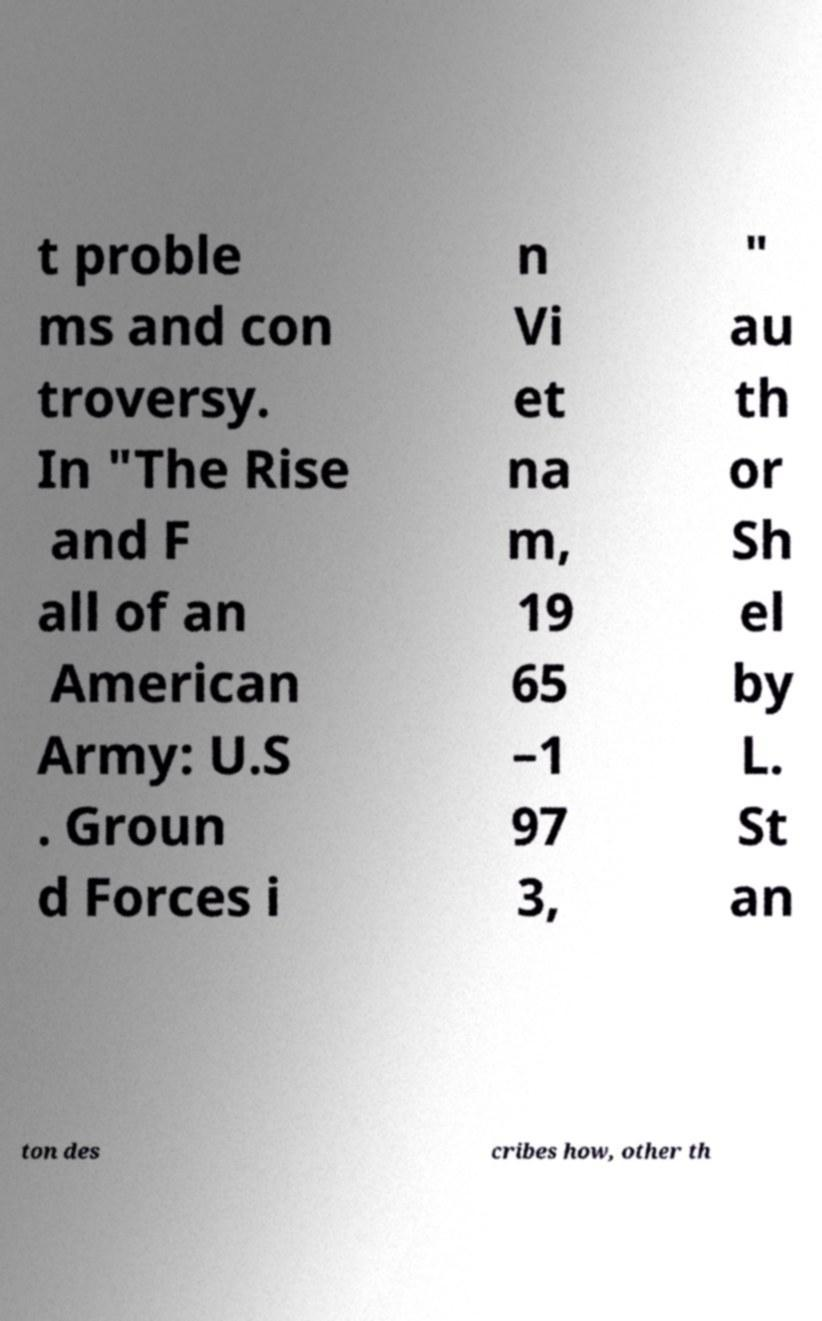Please identify and transcribe the text found in this image. t proble ms and con troversy. In "The Rise and F all of an American Army: U.S . Groun d Forces i n Vi et na m, 19 65 –1 97 3, " au th or Sh el by L. St an ton des cribes how, other th 